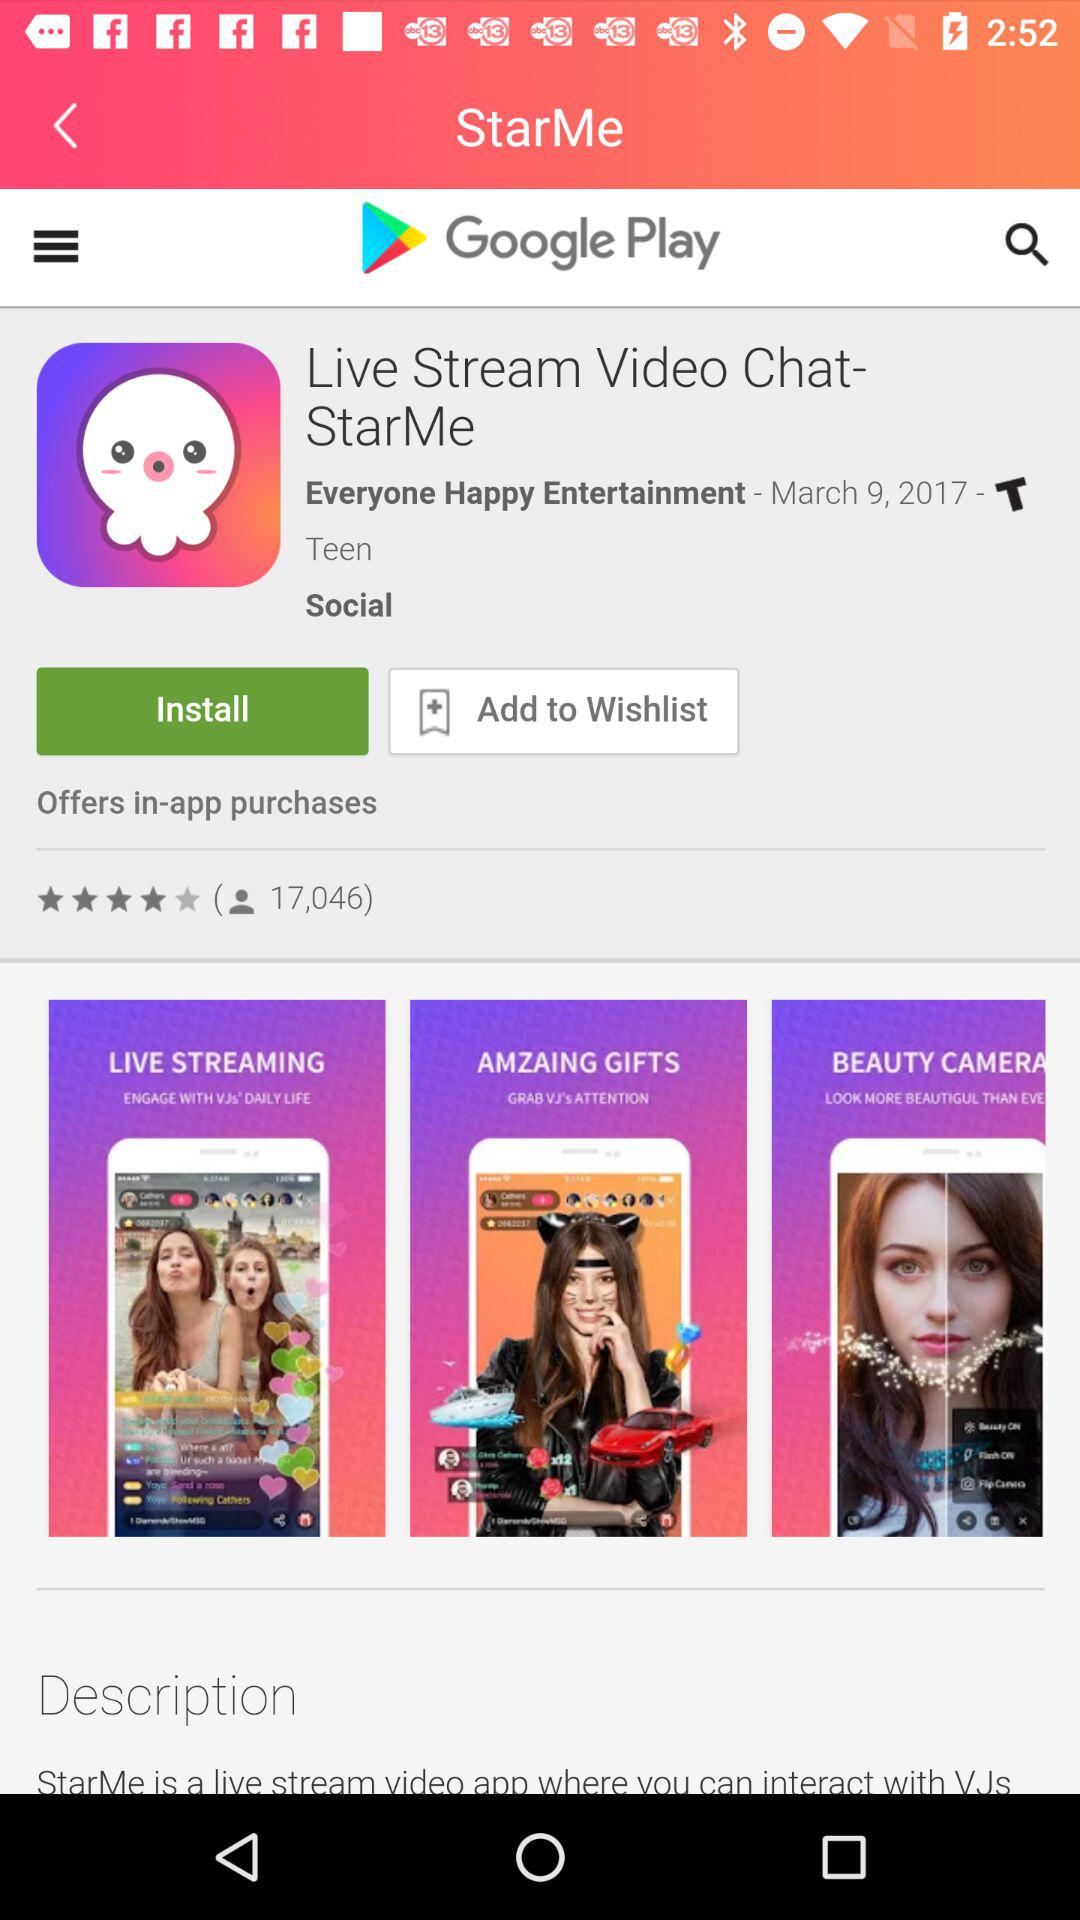How many users reviewed the application? There are 17,046 users who have reviewed the application. 